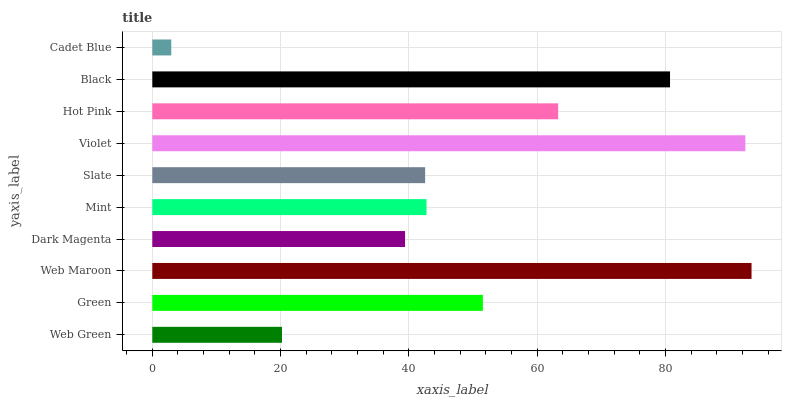Is Cadet Blue the minimum?
Answer yes or no. Yes. Is Web Maroon the maximum?
Answer yes or no. Yes. Is Green the minimum?
Answer yes or no. No. Is Green the maximum?
Answer yes or no. No. Is Green greater than Web Green?
Answer yes or no. Yes. Is Web Green less than Green?
Answer yes or no. Yes. Is Web Green greater than Green?
Answer yes or no. No. Is Green less than Web Green?
Answer yes or no. No. Is Green the high median?
Answer yes or no. Yes. Is Mint the low median?
Answer yes or no. Yes. Is Black the high median?
Answer yes or no. No. Is Slate the low median?
Answer yes or no. No. 